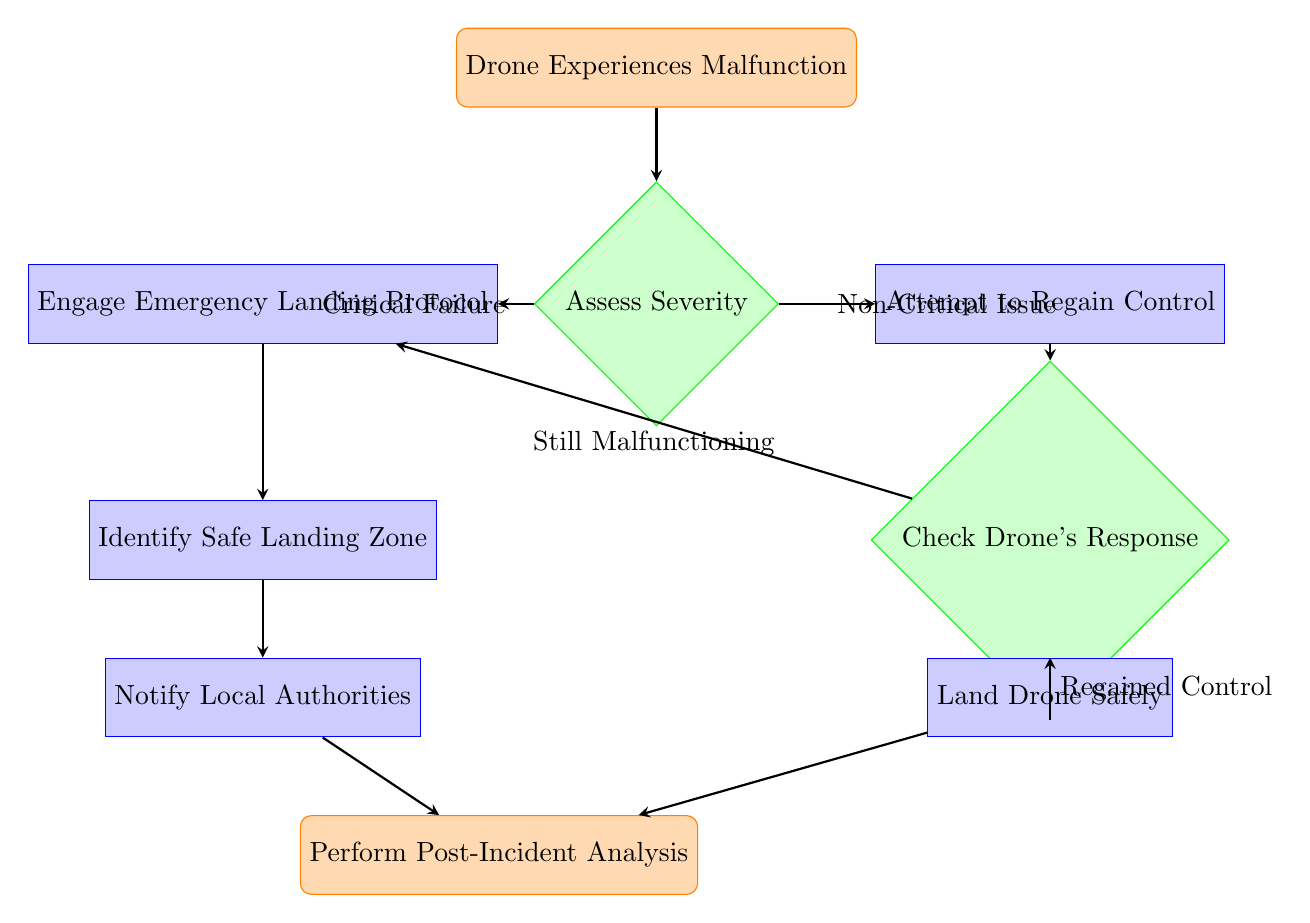What's the first step in the flow chart? The first step is indicated by the starting node, which states "Drone Experiences Malfunction." This is where the process begins when a malfunction occurs.
Answer: Drone Experiences Malfunction What is the decision point in the flow chart? The decision point is located at the node "Assess Severity," where a critical failure or a non-critical issue is evaluated. This leads to different paths depending on the severity of the malfunction.
Answer: Assess Severity How many process nodes are present in the diagram? The process nodes include "Engage Emergency Landing Protocol," "Attempt to Regain Control," "Identify Safe Landing Zone," "Notify Local Authorities," "Land Drone Safely," and "Perform Post-Incident Analysis." Counting these, there are five process nodes.
Answer: 5 What happens if the drone experiences a critical failure? If there is a critical failure, the flow directs to the process "Engage Emergency Landing Protocol," which is the next step taken after assessing severity.
Answer: Engage Emergency Landing Protocol What is the final action listed in the flow chart? The final action in the flow chart is "Perform Post-Incident Analysis," which comes after "Land Drone Safely." This indicates that post-event evaluation occurs last.
Answer: Perform Post-Incident Analysis What happens if the drone is still malfunctioning after attempting to regain control? If the drone is still malfunctioning, the flow directs back to "Engage Emergency Landing Protocol," indicating that the situation may require emergency landing procedures to be activated.
Answer: Engage Emergency Landing Protocol What are the two possible outcomes after the "Check Drone's Response"? After checking the drone's response, the two outcomes are "Regained Control" leading to "Land Drone Safely," or "Still Malfunctioning," which directs back to "Engage Emergency Landing Protocol."
Answer: Regained Control or Still Malfunctioning How is the local authority involved in the emergency procedure? The local authority is notified as part of the process "Notify Local Authorities," which occurs after identifying a safe landing zone, demonstrating accountability to regulatory bodies.
Answer: Notify Local Authorities 